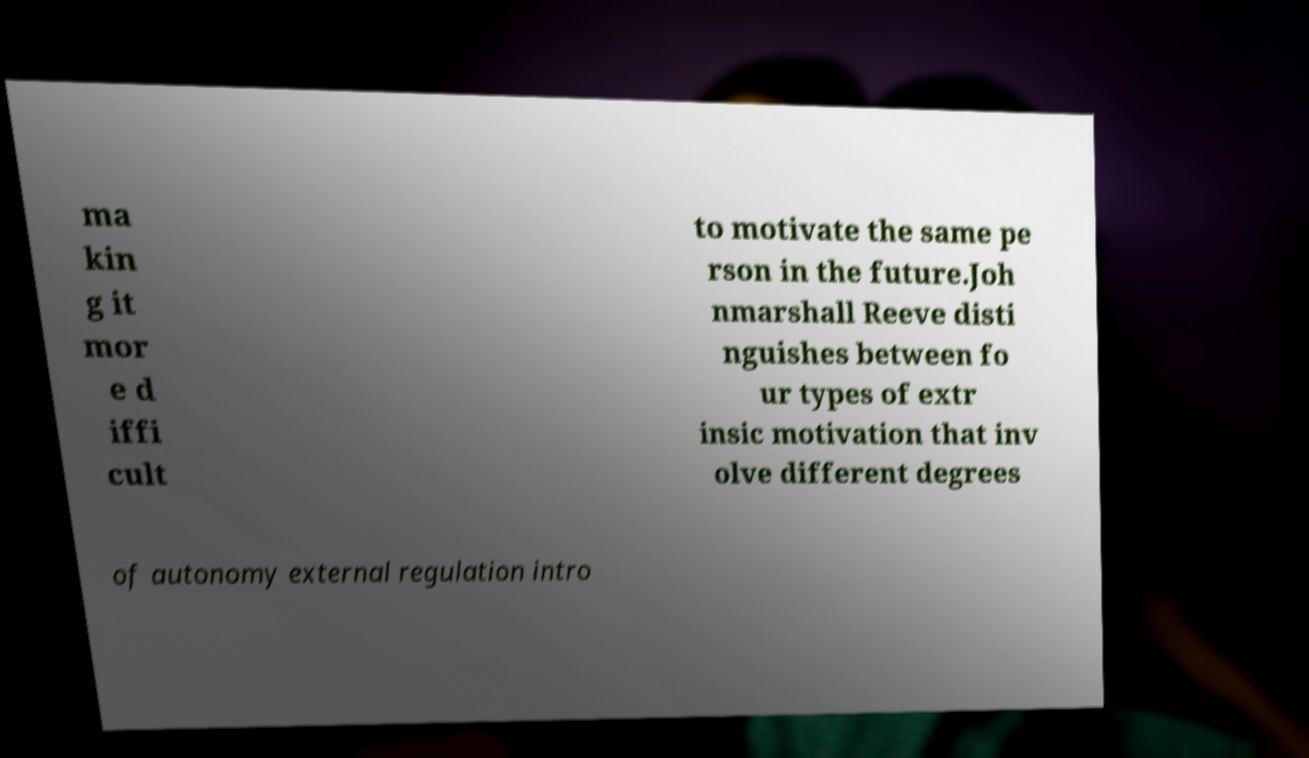Can you accurately transcribe the text from the provided image for me? ma kin g it mor e d iffi cult to motivate the same pe rson in the future.Joh nmarshall Reeve disti nguishes between fo ur types of extr insic motivation that inv olve different degrees of autonomy external regulation intro 